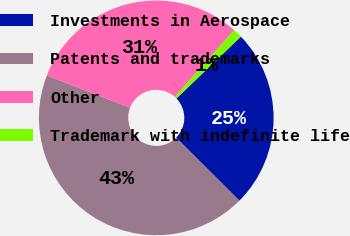Convert chart. <chart><loc_0><loc_0><loc_500><loc_500><pie_chart><fcel>Investments in Aerospace<fcel>Patents and trademarks<fcel>Other<fcel>Trademark with indefinite life<nl><fcel>24.65%<fcel>43.42%<fcel>30.67%<fcel>1.26%<nl></chart> 